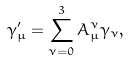<formula> <loc_0><loc_0><loc_500><loc_500>\gamma _ { \mu } ^ { \prime } = \sum _ { \nu = 0 } ^ { 3 } A _ { \mu } ^ { \nu } \gamma _ { \nu } ,</formula> 